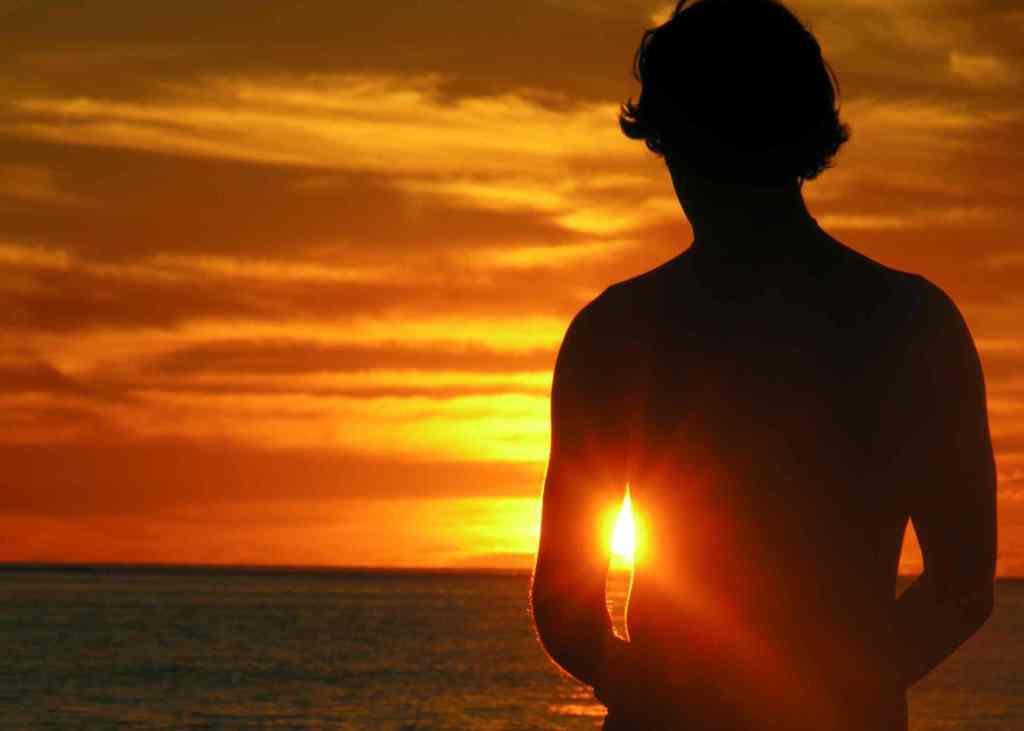Please provide a concise description of this image. In the front of the image we can see a person. In the background of the image there is a cloudy sky, sunlight and water.   